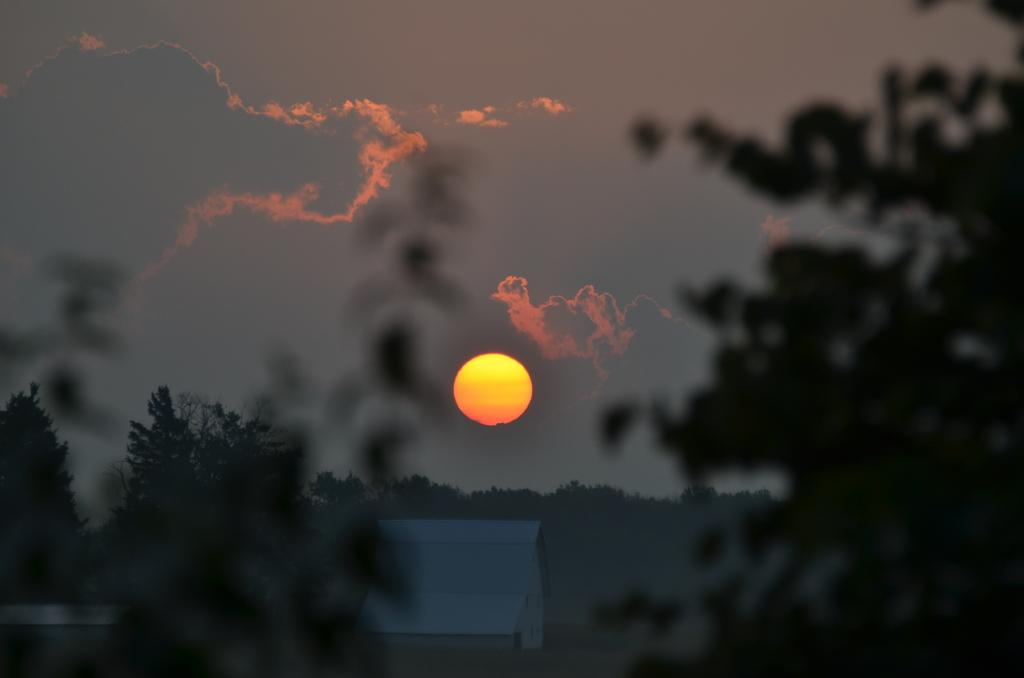What type of structure is present in the image? There is a house in the image. What can be seen in the background of the image? There are trees visible from left to right in the image. What is visible in the sky in the image? The sun is visible in the sky. How would you describe the weather in the image? The sky is cloudy in the image. What type of event is the writer attending in the image? There is no writer or event present in the image; it features a house and trees. Can you tell me how many ants are crawling on the writer's desk in the image? There is no writer or desk present in the image, so it is not possible to determine the number of ants. 